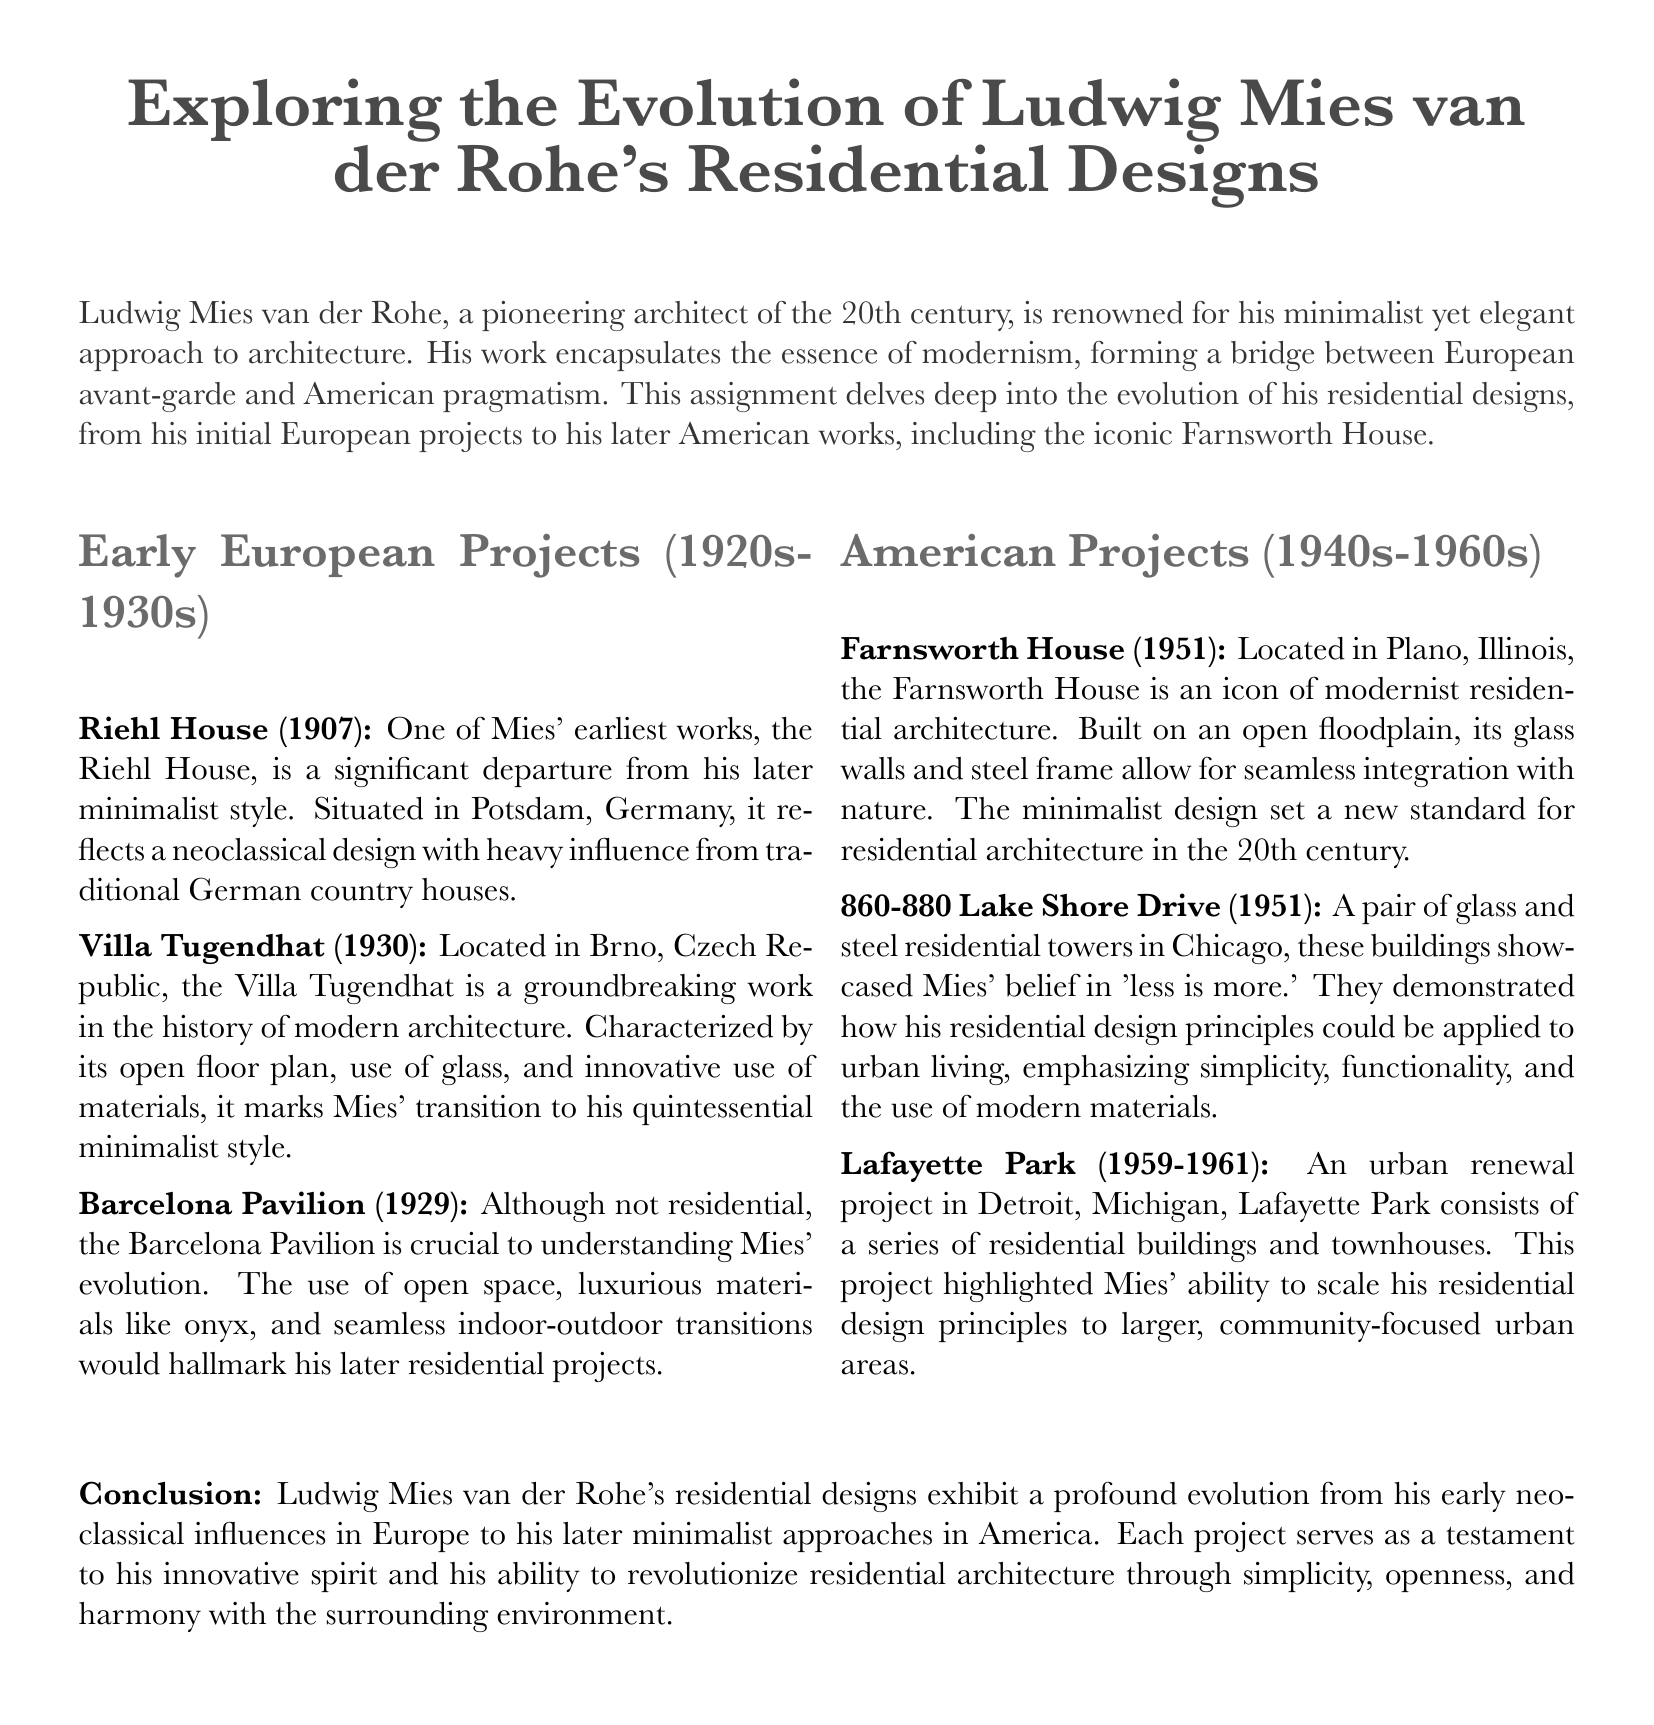What is the title of the document? The title of the document is prominently displayed at the beginning, indicating its focus on Mies van der Rohe's designs.
Answer: Exploring the Evolution of Ludwig Mies van der Rohe's Residential Designs What year was the Villa Tugendhat completed? The Villa Tugendhat is specifically dated in the early 1930s, marking a transition in Mies' style.
Answer: 1930 In which city is the Farnsworth House located? The document explicitly states the location of the Farnsworth House as part of its description.
Answer: Plano, Illinois What architectural principle is emphasized in Mies' work? The document highlights a key principle that Mies van der Rohe championed throughout his career.
Answer: Less is more Which project is categorized under American Projects? The section lists various projects under American designs, indicating their significance in Mies' evolution.
Answer: Farnsworth House What material usage is noted in the Barcelona Pavilion? The document mentions specific luxurious materials that highlight Mies' innovative design approach.
Answer: Onyx How many residential towers are mentioned in relation to Lake Shore Drive? The document specifies the number of towers that exemplify Mies' residential design principles.
Answer: Two What is the nature of the Lafayette Park project? The document describes this project in the context of its larger purpose within urban environments.
Answer: Urban renewal What decade did Mies begin to implement minimalist styles prominently? The document outlines the timeline of Mies' shift towards minimalism in residential architecture.
Answer: 1950s 